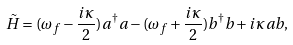Convert formula to latex. <formula><loc_0><loc_0><loc_500><loc_500>\tilde { H } = ( \omega _ { f } - \frac { i \kappa } { 2 } ) a ^ { \dagger } a - ( \omega _ { f } + \frac { i \kappa } { 2 } ) b ^ { \dagger } b + i \kappa a b ,</formula> 